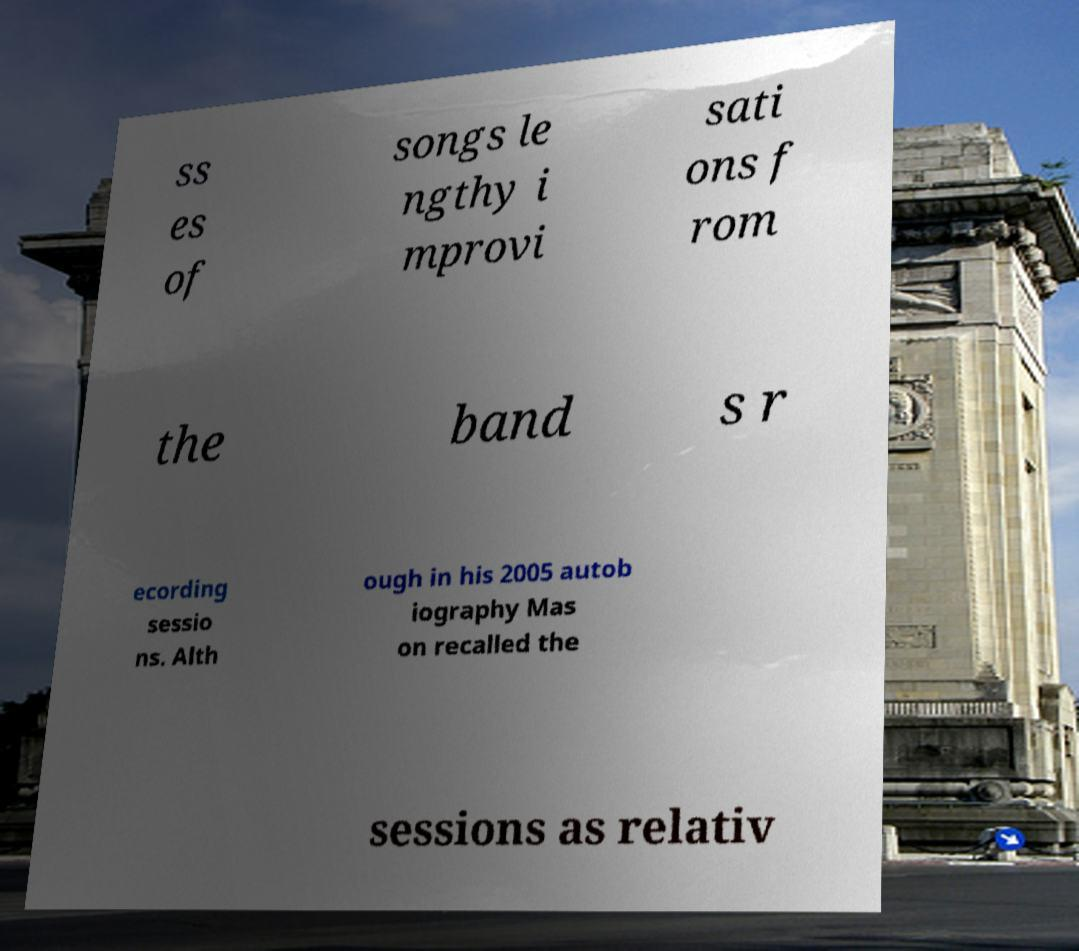Could you extract and type out the text from this image? ss es of songs le ngthy i mprovi sati ons f rom the band s r ecording sessio ns. Alth ough in his 2005 autob iography Mas on recalled the sessions as relativ 